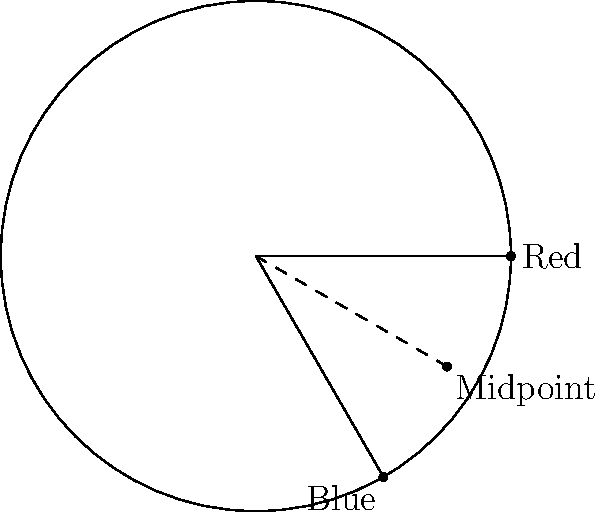On a circular color wheel with radius 3 units, the Red color is located at $(3,0)$ and Blue at $(-\frac{3}{2}, -\frac{3\sqrt{3}}{2})$. Find the coordinates of the midpoint between Red and Blue, which represents the color that would result from an equal mix of these two colors. To find the midpoint between two points, we use the midpoint formula:

$(\frac{x_1 + x_2}{2}, \frac{y_1 + y_2}{2})$

Where $(x_1, y_1)$ is the coordinate of the first point (Red) and $(x_2, y_2)$ is the coordinate of the second point (Blue).

1. Identify the coordinates:
   Red: $(3, 0)$
   Blue: $(-\frac{3}{2}, -\frac{3\sqrt{3}}{2})$

2. Apply the midpoint formula:
   $x = \frac{3 + (-\frac{3}{2})}{2} = \frac{3 - \frac{3}{2}}{2} = \frac{3}{4}$
   
   $y = \frac{0 + (-\frac{3\sqrt{3}}{2})}{2} = -\frac{3\sqrt{3}}{4}$

3. Therefore, the midpoint coordinates are $(\frac{3}{4}, -\frac{3\sqrt{3}}{4})$.

This point represents the color that would result from an equal mix of Red and Blue, which is Purple on the color wheel.
Answer: $(\frac{3}{4}, -\frac{3\sqrt{3}}{4})$ 